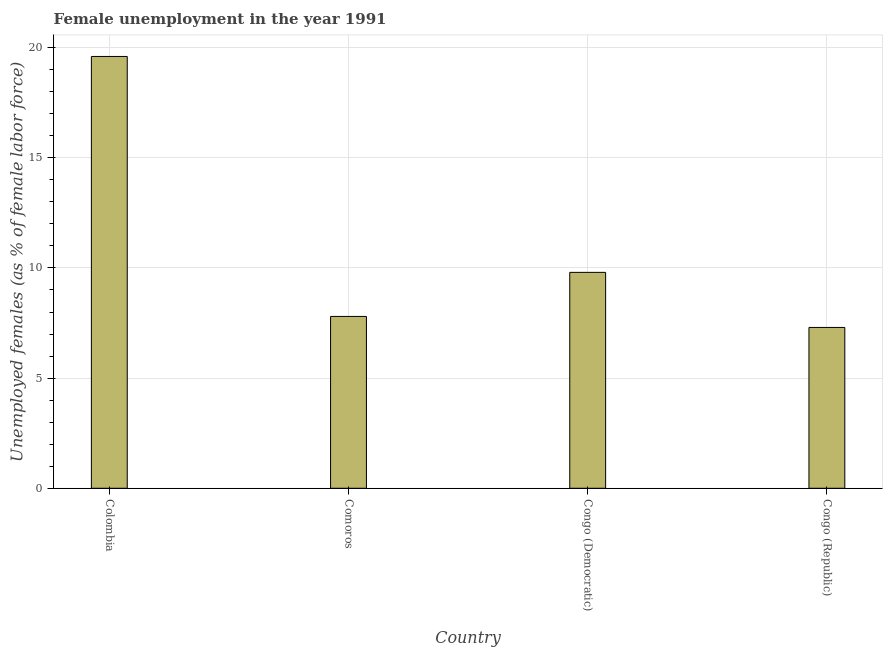Does the graph contain any zero values?
Make the answer very short. No. Does the graph contain grids?
Ensure brevity in your answer.  Yes. What is the title of the graph?
Offer a terse response. Female unemployment in the year 1991. What is the label or title of the Y-axis?
Ensure brevity in your answer.  Unemployed females (as % of female labor force). What is the unemployed females population in Congo (Democratic)?
Provide a short and direct response. 9.8. Across all countries, what is the maximum unemployed females population?
Provide a short and direct response. 19.6. Across all countries, what is the minimum unemployed females population?
Keep it short and to the point. 7.3. In which country was the unemployed females population minimum?
Keep it short and to the point. Congo (Republic). What is the sum of the unemployed females population?
Your answer should be compact. 44.5. What is the difference between the unemployed females population in Congo (Democratic) and Congo (Republic)?
Provide a succinct answer. 2.5. What is the average unemployed females population per country?
Your response must be concise. 11.12. What is the median unemployed females population?
Make the answer very short. 8.8. In how many countries, is the unemployed females population greater than 9 %?
Give a very brief answer. 2. What is the ratio of the unemployed females population in Colombia to that in Comoros?
Ensure brevity in your answer.  2.51. Is the unemployed females population in Colombia less than that in Congo (Republic)?
Keep it short and to the point. No. Is the difference between the unemployed females population in Comoros and Congo (Republic) greater than the difference between any two countries?
Keep it short and to the point. No. What is the difference between the highest and the second highest unemployed females population?
Give a very brief answer. 9.8. What is the difference between the highest and the lowest unemployed females population?
Make the answer very short. 12.3. In how many countries, is the unemployed females population greater than the average unemployed females population taken over all countries?
Your answer should be very brief. 1. How many bars are there?
Offer a very short reply. 4. How many countries are there in the graph?
Make the answer very short. 4. What is the Unemployed females (as % of female labor force) of Colombia?
Keep it short and to the point. 19.6. What is the Unemployed females (as % of female labor force) of Comoros?
Your answer should be compact. 7.8. What is the Unemployed females (as % of female labor force) in Congo (Democratic)?
Provide a succinct answer. 9.8. What is the Unemployed females (as % of female labor force) of Congo (Republic)?
Ensure brevity in your answer.  7.3. What is the difference between the Unemployed females (as % of female labor force) in Colombia and Comoros?
Ensure brevity in your answer.  11.8. What is the difference between the Unemployed females (as % of female labor force) in Colombia and Congo (Democratic)?
Offer a very short reply. 9.8. What is the difference between the Unemployed females (as % of female labor force) in Comoros and Congo (Republic)?
Give a very brief answer. 0.5. What is the difference between the Unemployed females (as % of female labor force) in Congo (Democratic) and Congo (Republic)?
Your response must be concise. 2.5. What is the ratio of the Unemployed females (as % of female labor force) in Colombia to that in Comoros?
Provide a short and direct response. 2.51. What is the ratio of the Unemployed females (as % of female labor force) in Colombia to that in Congo (Democratic)?
Your response must be concise. 2. What is the ratio of the Unemployed females (as % of female labor force) in Colombia to that in Congo (Republic)?
Offer a very short reply. 2.69. What is the ratio of the Unemployed females (as % of female labor force) in Comoros to that in Congo (Democratic)?
Make the answer very short. 0.8. What is the ratio of the Unemployed females (as % of female labor force) in Comoros to that in Congo (Republic)?
Ensure brevity in your answer.  1.07. What is the ratio of the Unemployed females (as % of female labor force) in Congo (Democratic) to that in Congo (Republic)?
Your answer should be compact. 1.34. 